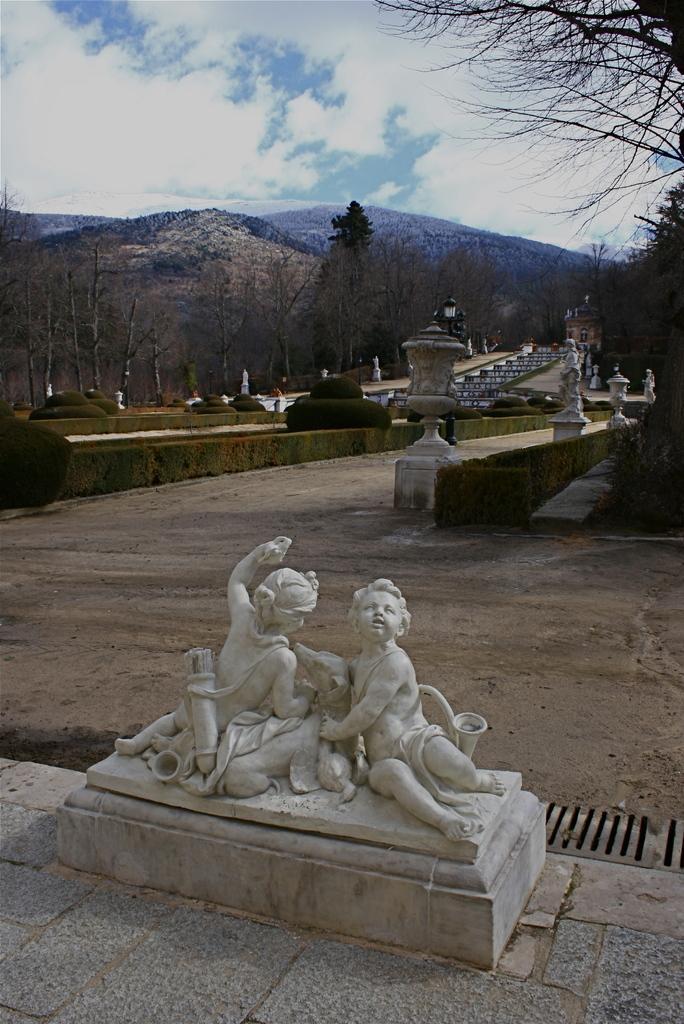Could you give a brief overview of what you see in this image? In this picture we can see statues, plants, trees, building and some objects. In the background we can see mountains, sky. 